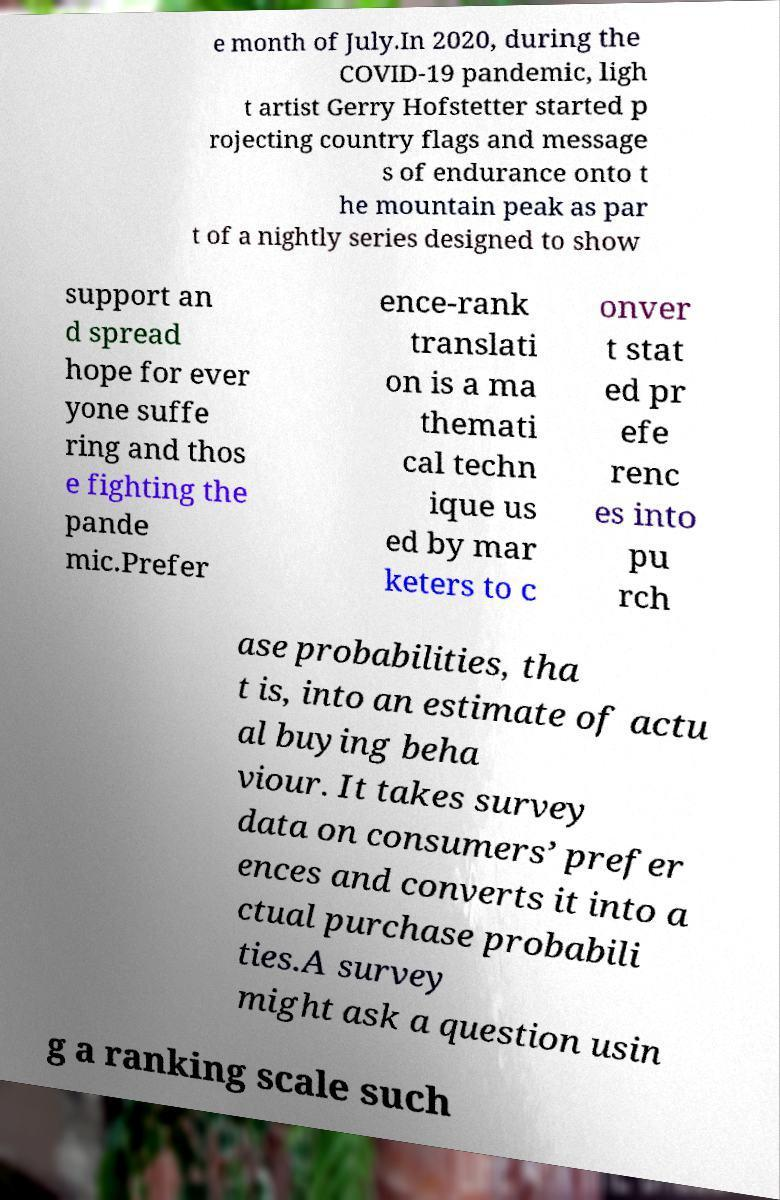I need the written content from this picture converted into text. Can you do that? e month of July.In 2020, during the COVID-19 pandemic, ligh t artist Gerry Hofstetter started p rojecting country flags and message s of endurance onto t he mountain peak as par t of a nightly series designed to show support an d spread hope for ever yone suffe ring and thos e fighting the pande mic.Prefer ence-rank translati on is a ma themati cal techn ique us ed by mar keters to c onver t stat ed pr efe renc es into pu rch ase probabilities, tha t is, into an estimate of actu al buying beha viour. It takes survey data on consumers’ prefer ences and converts it into a ctual purchase probabili ties.A survey might ask a question usin g a ranking scale such 